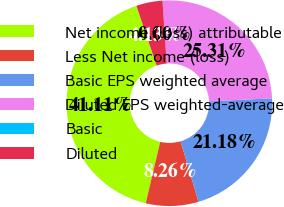Convert chart. <chart><loc_0><loc_0><loc_500><loc_500><pie_chart><fcel>Net income (loss) attributable<fcel>Less Net income (loss)<fcel>Basic EPS weighted average<fcel>Diluted EPS weighted-average<fcel>Basic<fcel>Diluted<nl><fcel>41.11%<fcel>8.26%<fcel>21.18%<fcel>25.31%<fcel>0.0%<fcel>4.13%<nl></chart> 